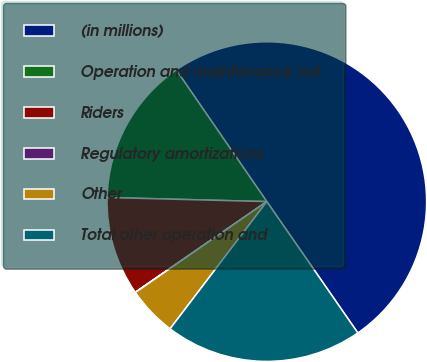Convert chart to OTSL. <chart><loc_0><loc_0><loc_500><loc_500><pie_chart><fcel>(in millions)<fcel>Operation and maintenance not<fcel>Riders<fcel>Regulatory amortizations<fcel>Other<fcel>Total other operation and<nl><fcel>49.94%<fcel>15.0%<fcel>10.01%<fcel>0.03%<fcel>5.02%<fcel>19.99%<nl></chart> 